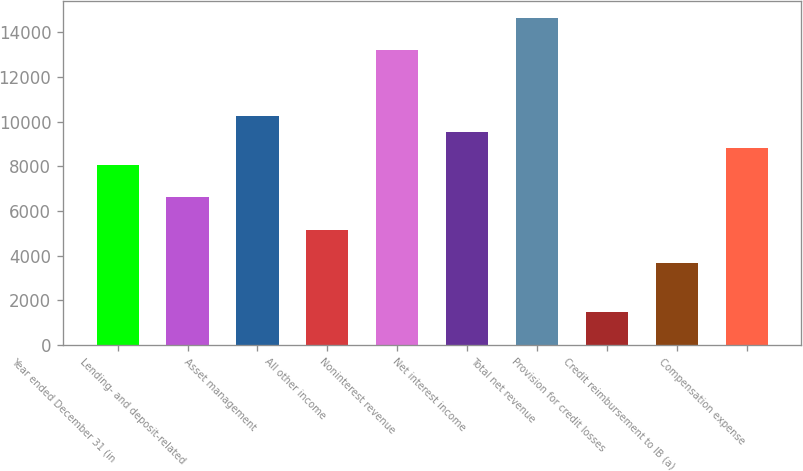Convert chart to OTSL. <chart><loc_0><loc_0><loc_500><loc_500><bar_chart><fcel>Year ended December 31 (in<fcel>Lending- and deposit-related<fcel>Asset management<fcel>All other income<fcel>Noninterest revenue<fcel>Net interest income<fcel>Total net revenue<fcel>Provision for credit losses<fcel>Credit reimbursement to IB (a)<fcel>Compensation expense<nl><fcel>8075.9<fcel>6612.1<fcel>10271.6<fcel>5148.3<fcel>13199.2<fcel>9539.7<fcel>14663<fcel>1488.8<fcel>3684.5<fcel>8807.8<nl></chart> 